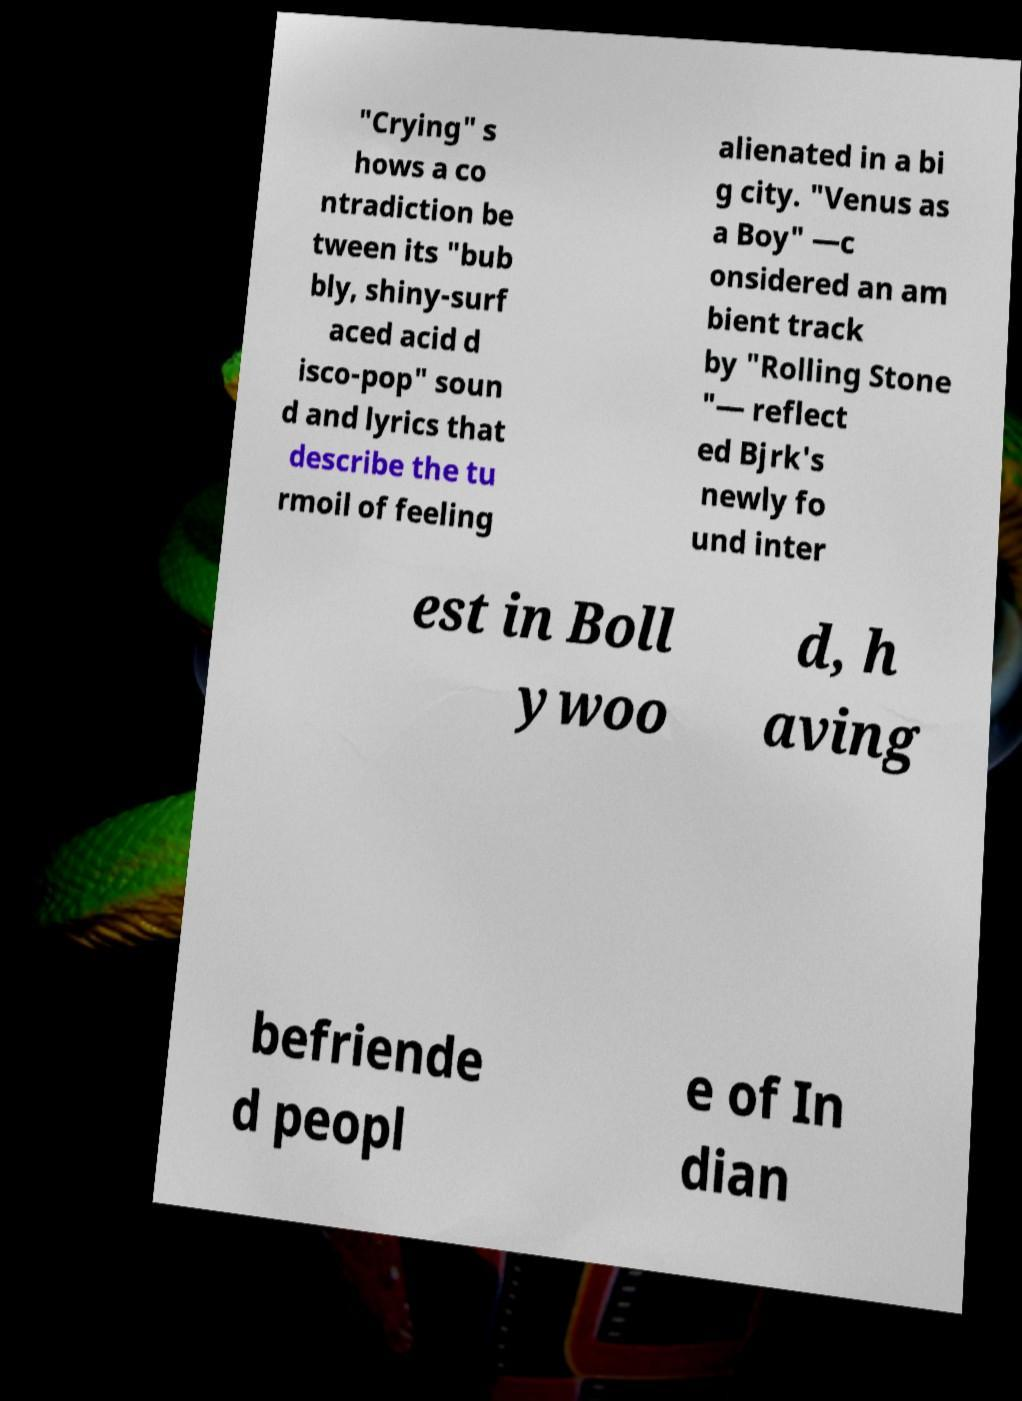Please read and relay the text visible in this image. What does it say? "Crying" s hows a co ntradiction be tween its "bub bly, shiny-surf aced acid d isco-pop" soun d and lyrics that describe the tu rmoil of feeling alienated in a bi g city. "Venus as a Boy" —c onsidered an am bient track by "Rolling Stone "— reflect ed Bjrk's newly fo und inter est in Boll ywoo d, h aving befriende d peopl e of In dian 